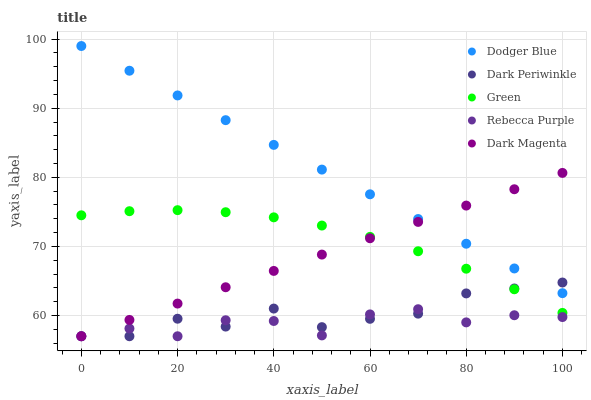Does Rebecca Purple have the minimum area under the curve?
Answer yes or no. Yes. Does Dodger Blue have the maximum area under the curve?
Answer yes or no. Yes. Does Dark Periwinkle have the minimum area under the curve?
Answer yes or no. No. Does Dark Periwinkle have the maximum area under the curve?
Answer yes or no. No. Is Dark Magenta the smoothest?
Answer yes or no. Yes. Is Rebecca Purple the roughest?
Answer yes or no. Yes. Is Dodger Blue the smoothest?
Answer yes or no. No. Is Dodger Blue the roughest?
Answer yes or no. No. Does Dark Periwinkle have the lowest value?
Answer yes or no. Yes. Does Dodger Blue have the lowest value?
Answer yes or no. No. Does Dodger Blue have the highest value?
Answer yes or no. Yes. Does Dark Periwinkle have the highest value?
Answer yes or no. No. Is Green less than Dodger Blue?
Answer yes or no. Yes. Is Dodger Blue greater than Rebecca Purple?
Answer yes or no. Yes. Does Dodger Blue intersect Dark Periwinkle?
Answer yes or no. Yes. Is Dodger Blue less than Dark Periwinkle?
Answer yes or no. No. Is Dodger Blue greater than Dark Periwinkle?
Answer yes or no. No. Does Green intersect Dodger Blue?
Answer yes or no. No. 